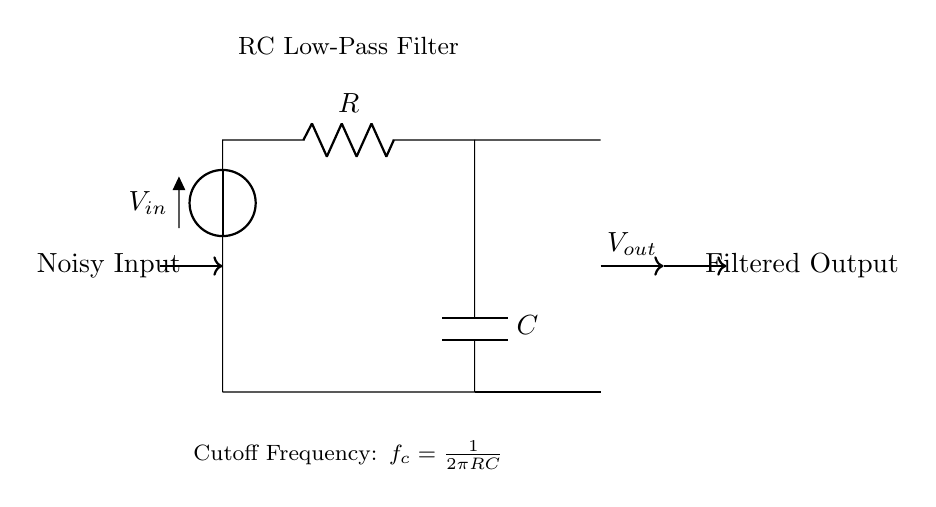What is the input voltage in this circuit? The input voltage is denoted by V_{in}, which is the voltage supplied to the circuit from the left side.
Answer: V_{in} What type of filter is implemented in this circuit? The circuit is an RC low-pass filter, which allows low-frequency signals to pass while attenuating high-frequency noise.
Answer: Low-pass filter What is the relationship between the resistor and capacitor in this circuit? The resistor (R) and capacitor (C) are in series and form a time constant for the filter, which determines the cutoff frequency affecting how the circuit responds to changes in the input signal.
Answer: Series What does the output signal represent? The output signal, noted as V_{out}, represents the filtered version of the noisy input, showing the signal after passing through the low-pass filter.
Answer: Filtered Output What is the formula for the cutoff frequency in this circuit? The cutoff frequency, denoted as f_c, is calculated using the formula f_c = 1/(2\pi RC), where R is the resistance and C is the capacitance in the circuit.
Answer: f_c = 1/(2\pi RC) At what frequency will the output voltage be reduced to approximately 70.7% of the input voltage? This occurs at the cutoff frequency (f_c) defined in the circuit, meaning that at this frequency, the filter begins to significantly attenuate the incoming signal.
Answer: Cutoff frequency What effect does increasing the resistance have on the cutoff frequency? Increasing the resistance (R) in the circuit results in a lower cutoff frequency (f_c), which causes the filter to allow signals of an even lower frequency to pass through while further blocking higher frequencies.
Answer: Lower cutoff frequency 